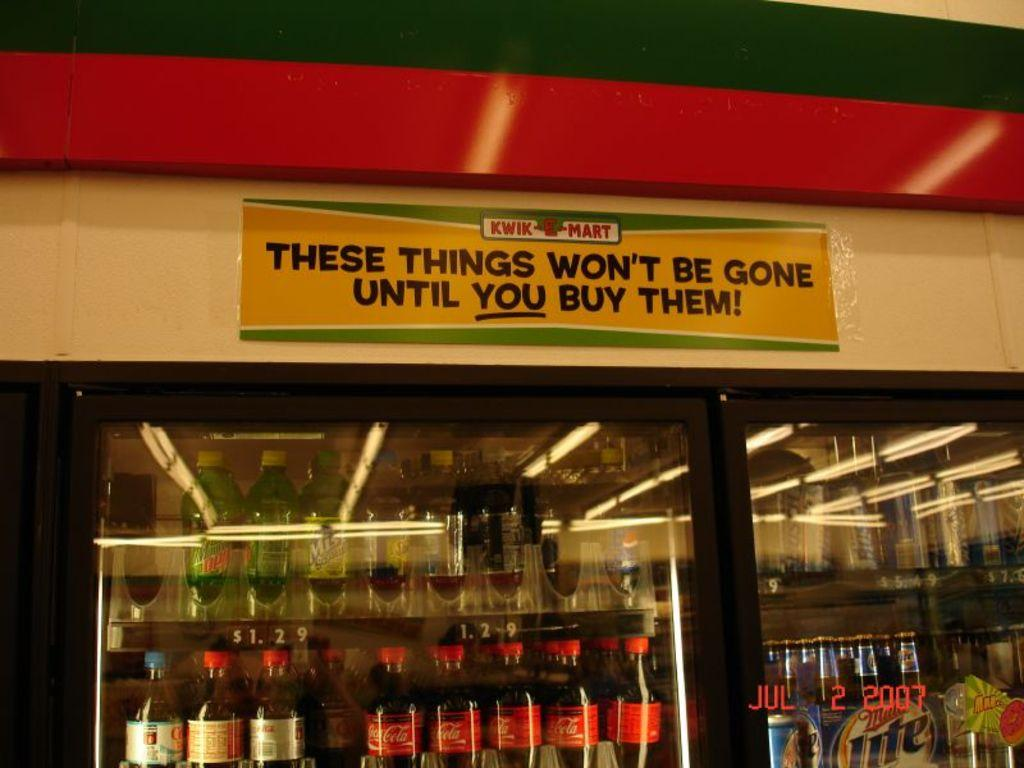<image>
Provide a brief description of the given image. a bunch of soda in a fridge with Kwik E Mart over it 